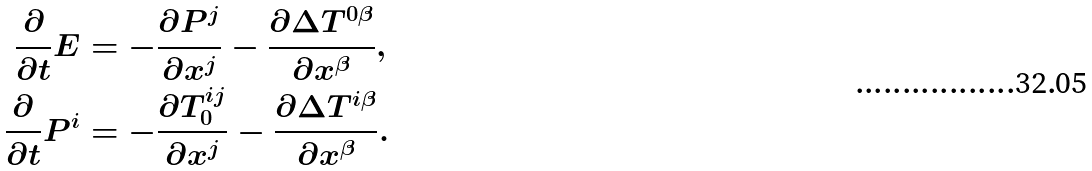Convert formula to latex. <formula><loc_0><loc_0><loc_500><loc_500>\frac { \partial } { \partial t } E & = - \frac { \partial P ^ { j } } { \partial x ^ { j } } - \frac { \partial \Delta T ^ { 0 \beta } } { \partial x ^ { \beta } } , \\ \frac { \partial } { \partial t } P ^ { i } & = - \frac { \partial T _ { 0 } ^ { i j } } { \partial x ^ { j } } - \frac { \partial \Delta T ^ { i \beta } } { \partial x ^ { \beta } } .</formula> 